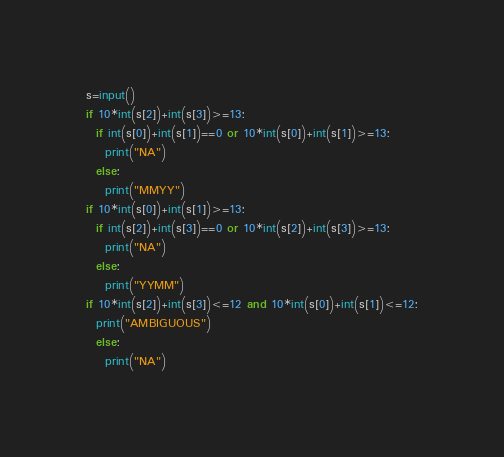Convert code to text. <code><loc_0><loc_0><loc_500><loc_500><_Python_>s=input()
if 10*int(s[2])+int(s[3])>=13:
  if int(s[0])+int(s[1])==0 or 10*int(s[0])+int(s[1])>=13:
    print("NA")
  else:
    print("MMYY")
if 10*int(s[0])+int(s[1])>=13:
  if int(s[2])+int(s[3])==0 or 10*int(s[2])+int(s[3])>=13:
    print("NA")
  else:
    print("YYMM")
if 10*int(s[2])+int(s[3])<=12 and 10*int(s[0])+int(s[1])<=12:
  print("AMBIGUOUS")
  else:
    print("NA")</code> 